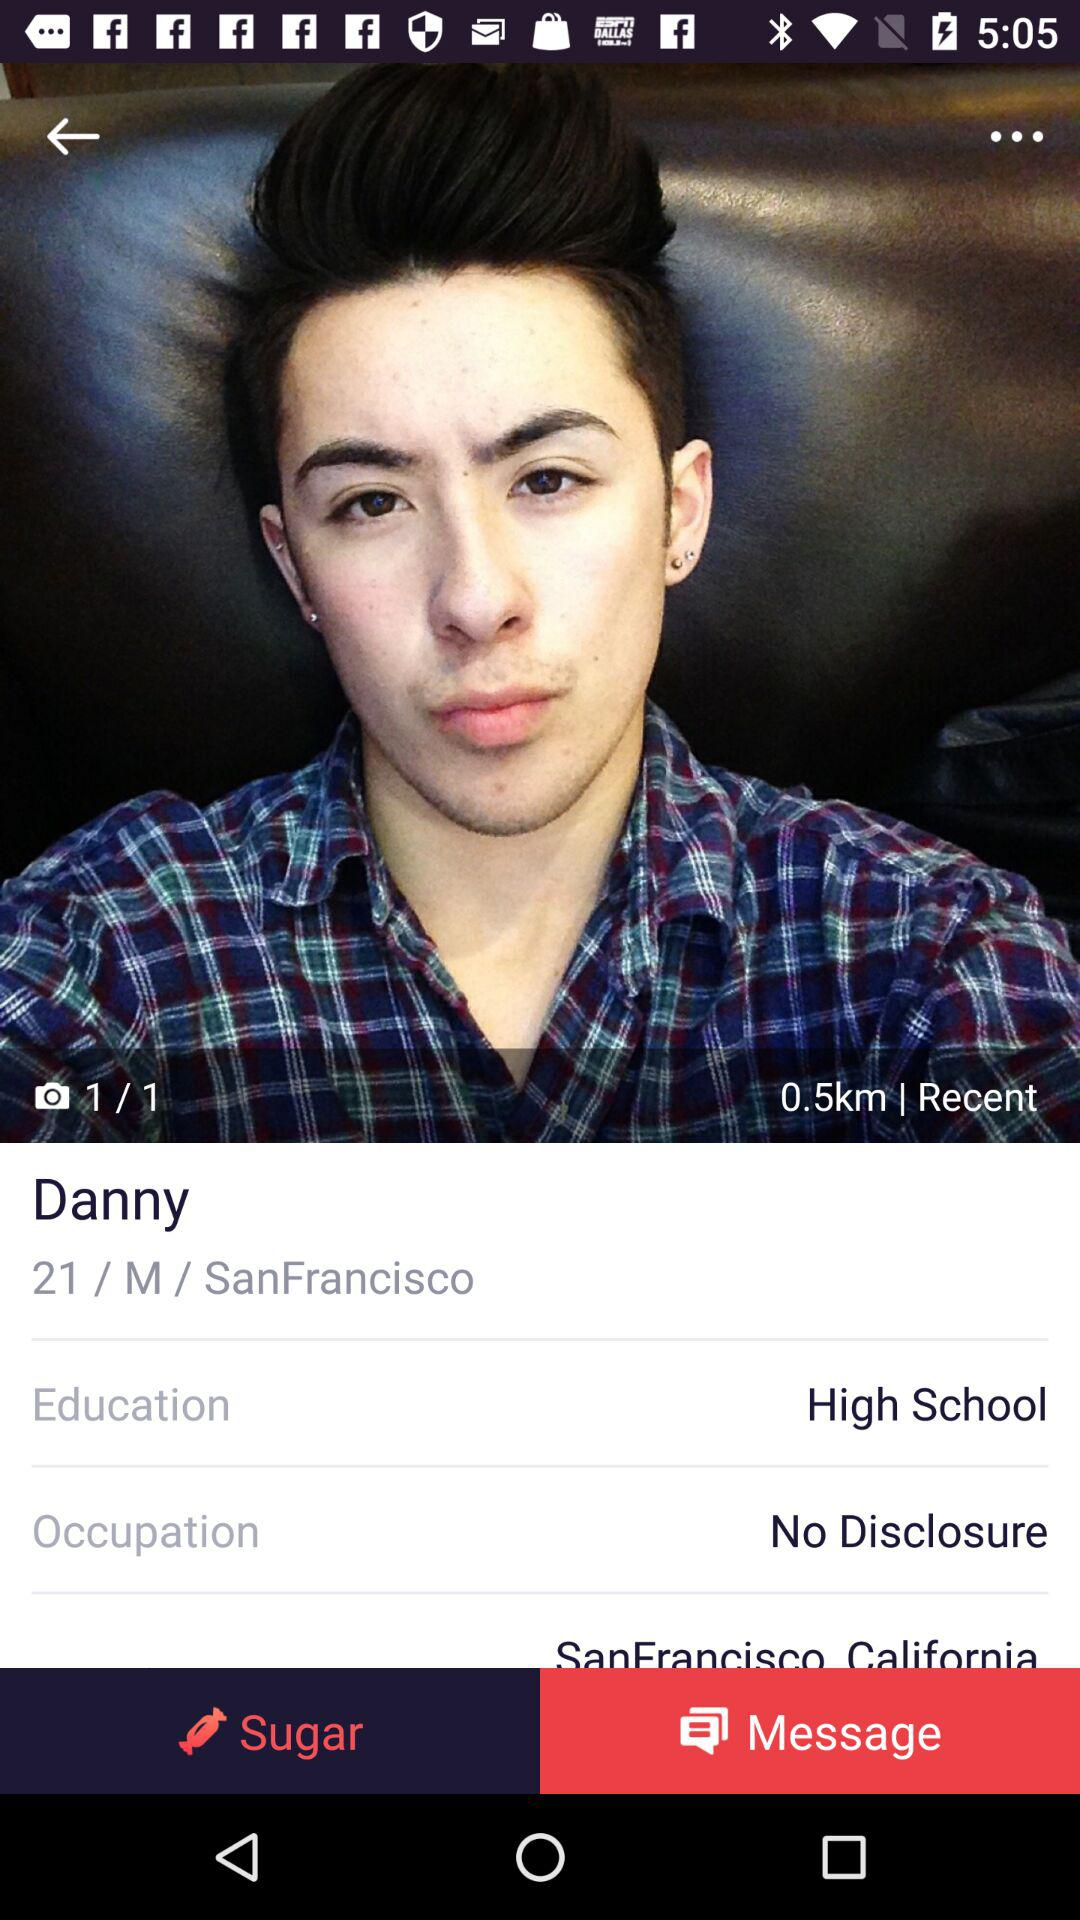What is the profile name? The profile name is Danny. 